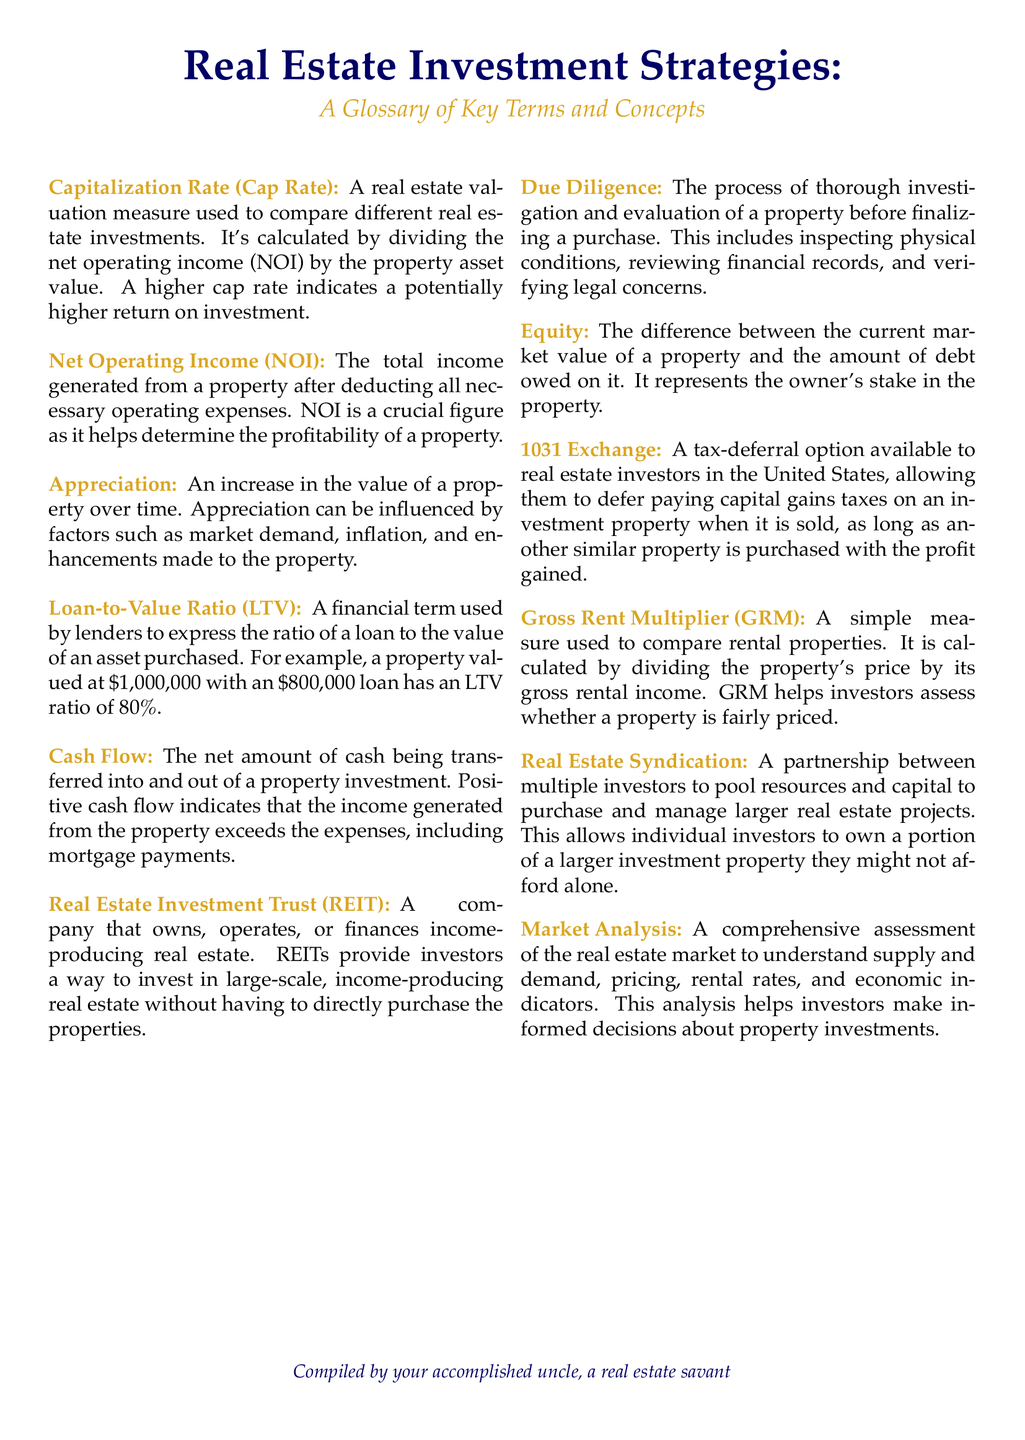What is the Cap Rate? The Cap Rate is calculated by dividing the net operating income (NOI) by the property asset value and is a real estate valuation measure.
Answer: A real estate valuation measure What does NOI stand for? NOI stands for Net Operating Income, which is crucial for determining the profitability of a property.
Answer: Net Operating Income What is the meaning of Appreciation? Appreciation refers to an increase in the value of a property over time, influenced by market demand and other factors.
Answer: Increase in the value of a property What is the LTV ratio for an $800,000 loan on a $1,000,000 property? The LTV ratio is calculated as the loan amount divided by the property value, which in this case is 80%.
Answer: 80% What is a Real Estate Investment Trust (REIT)? A REIT is a company that owns, operates, or finances income-producing real estate, allowing investment without direct property purchase.
Answer: A company that owns, operates, or finances income-producing real estate What is Due Diligence? Due Diligence is the process of thorough investigation and evaluation of a property before purchase, including inspections and legal verifications.
Answer: Thorough investigation and evaluation of a property What is a 1031 Exchange? A 1031 Exchange is a tax-deferral option for real estate investors in the U.S. to defer capital gains taxes when a similar property is purchased.
Answer: A tax-deferral option How is the Gross Rent Multiplier (GRM) calculated? The GRM is calculated by dividing the property's price by its gross rental income, helping assess property pricing.
Answer: Price divided by gross rental income What does Market Analysis assess? Market Analysis assesses the real estate market to understand supply, demand, pricing, rental rates, and economic indicators.
Answer: Real estate market conditions What does Equity represent? Equity represents the difference between the current market value of a property and the debt owed on it.
Answer: Difference between market value and debt owed 